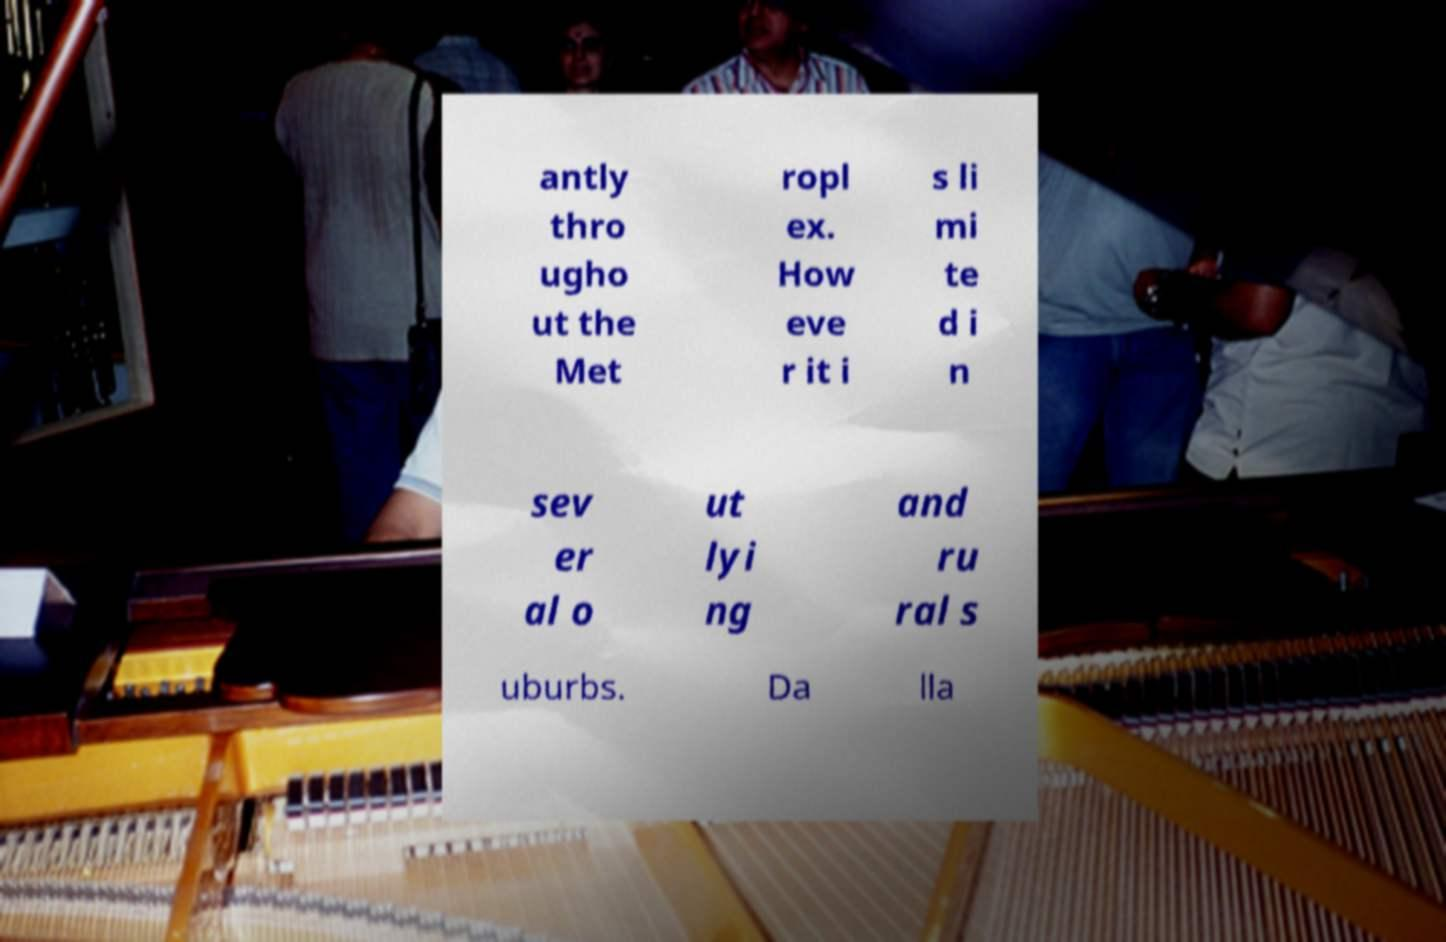For documentation purposes, I need the text within this image transcribed. Could you provide that? antly thro ugho ut the Met ropl ex. How eve r it i s li mi te d i n sev er al o ut lyi ng and ru ral s uburbs. Da lla 